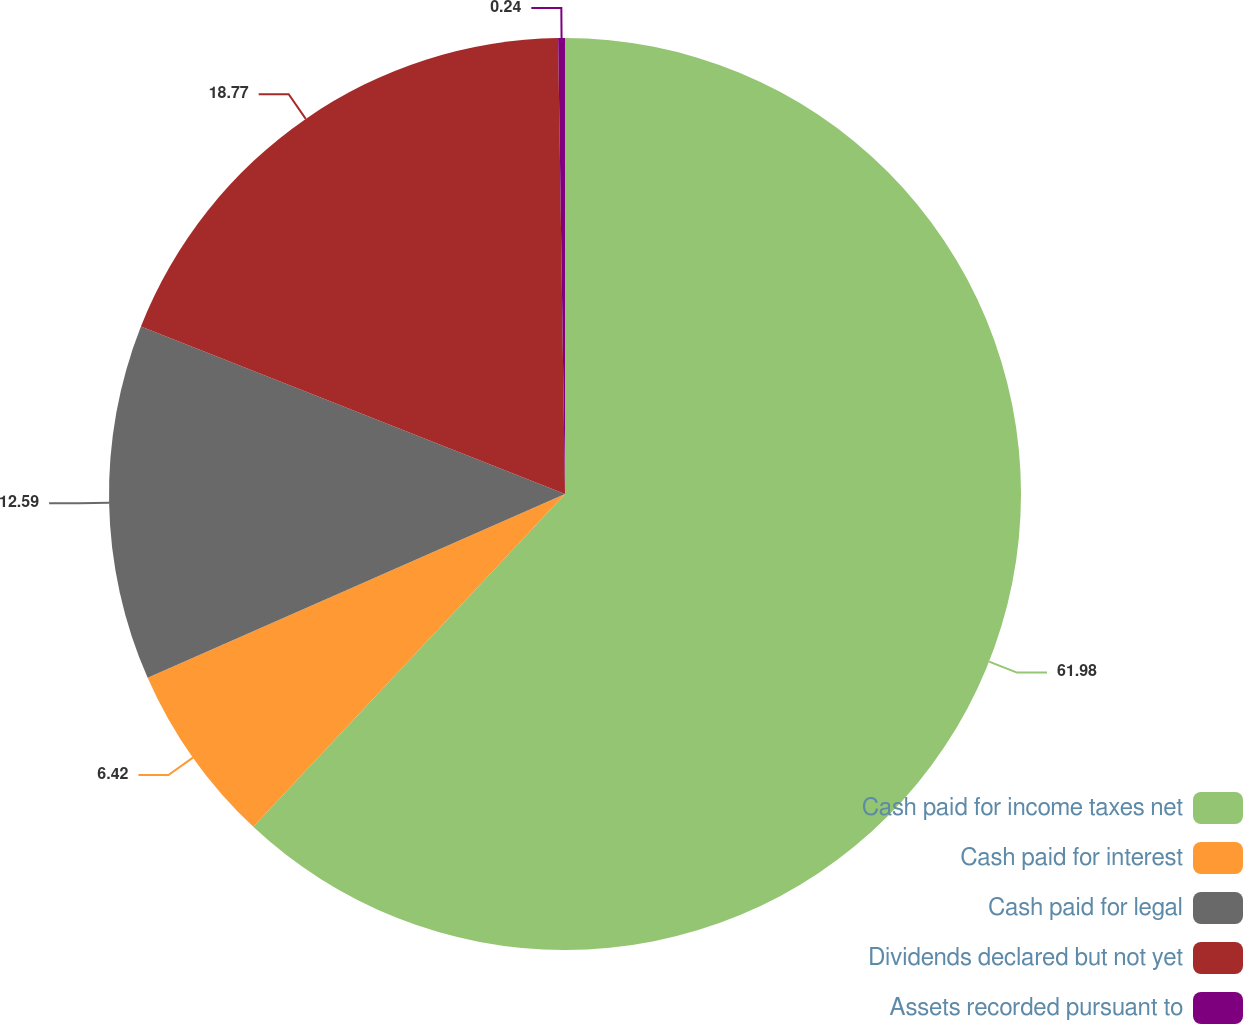Convert chart. <chart><loc_0><loc_0><loc_500><loc_500><pie_chart><fcel>Cash paid for income taxes net<fcel>Cash paid for interest<fcel>Cash paid for legal<fcel>Dividends declared but not yet<fcel>Assets recorded pursuant to<nl><fcel>61.98%<fcel>6.42%<fcel>12.59%<fcel>18.77%<fcel>0.24%<nl></chart> 